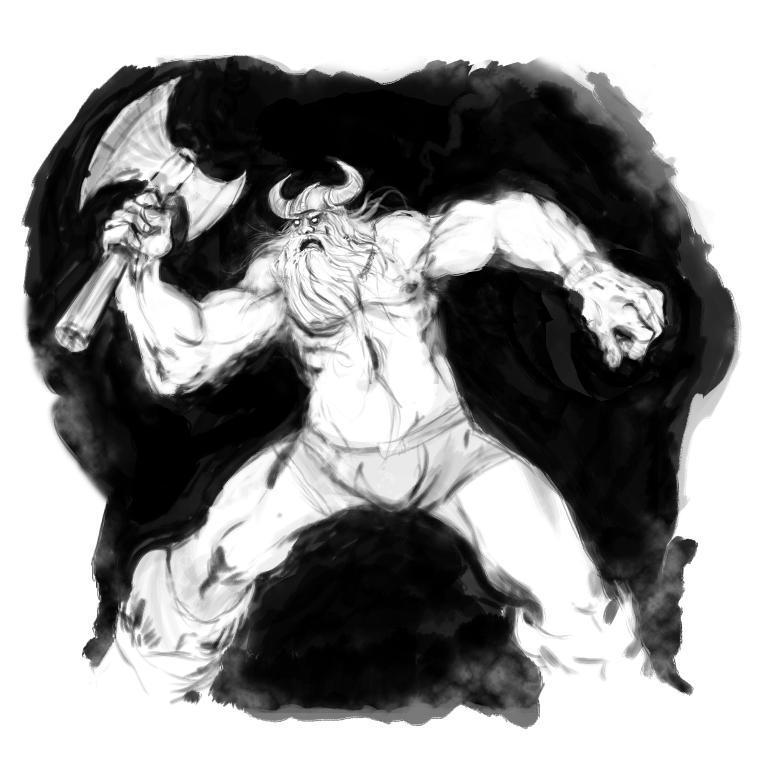Describe this image in one or two sentences. In this image we can see a painting of a person, he is holding an ax, and the background is white in color. 